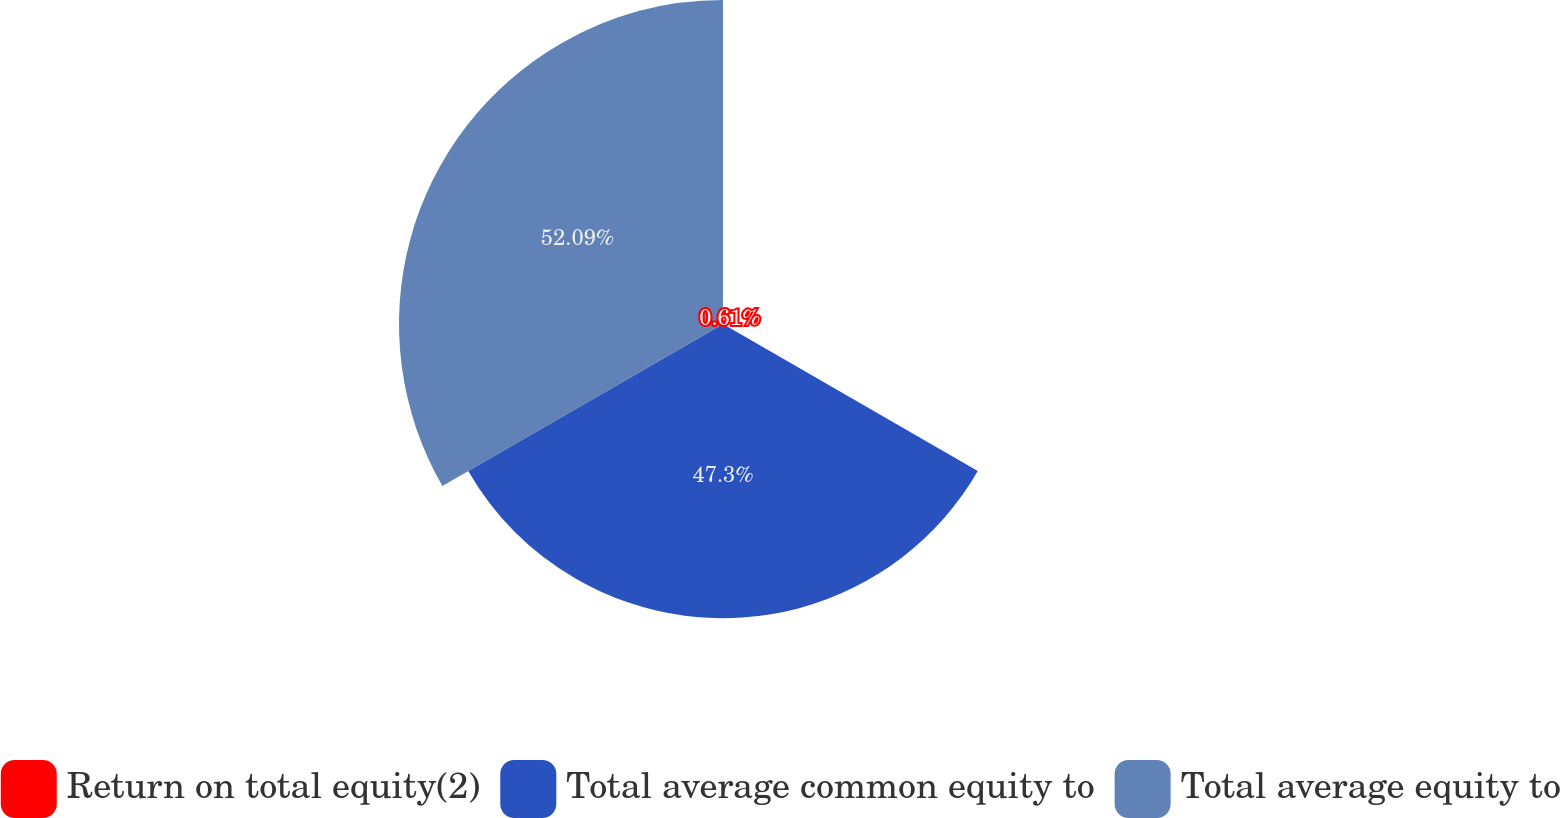Convert chart. <chart><loc_0><loc_0><loc_500><loc_500><pie_chart><fcel>Return on total equity(2)<fcel>Total average common equity to<fcel>Total average equity to<nl><fcel>0.61%<fcel>47.3%<fcel>52.09%<nl></chart> 